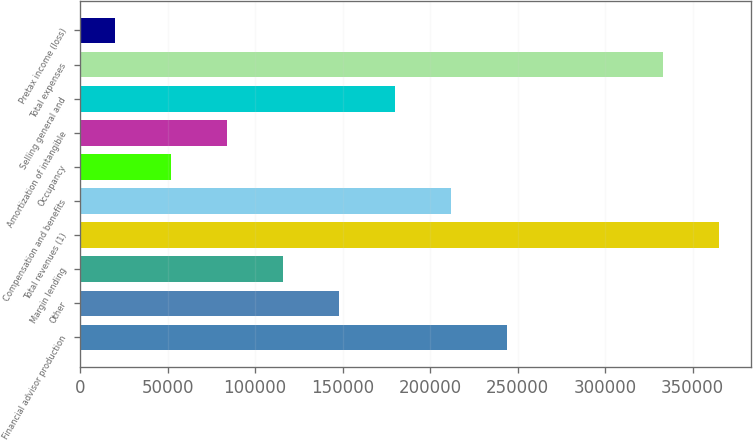Convert chart to OTSL. <chart><loc_0><loc_0><loc_500><loc_500><bar_chart><fcel>Financial advisor production<fcel>Other<fcel>Margin lending<fcel>Total revenues (1)<fcel>Compensation and benefits<fcel>Occupancy<fcel>Amortization of intangible<fcel>Selling general and<fcel>Total expenses<fcel>Pretax income (loss)<nl><fcel>243699<fcel>147747<fcel>115763<fcel>365274<fcel>211715<fcel>51795<fcel>83779<fcel>179731<fcel>333290<fcel>19811<nl></chart> 